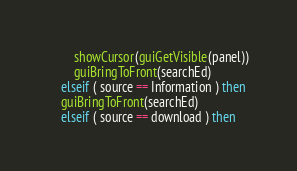Convert code to text. <code><loc_0><loc_0><loc_500><loc_500><_Lua_>        showCursor(guiGetVisible(panel))
        guiBringToFront(searchEd)
    elseif ( source == Information ) then
	guiBringToFront(searchEd)
    elseif ( source == download ) then</code> 